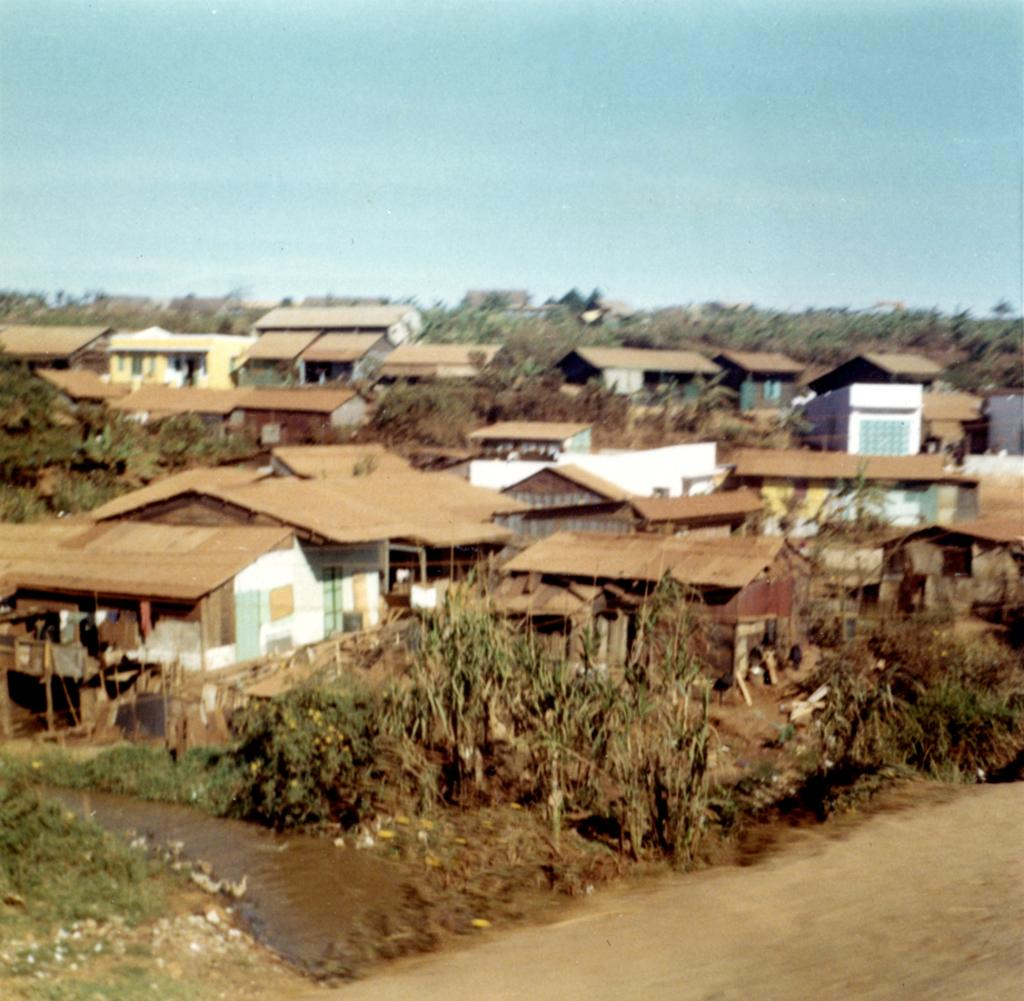What type of vegetation can be seen in the image? There are trees in the image. What type of structures are present in the image? There are houses in the image. What is the primary mode of transportation visible in the image? There is a road in the image. What is visible in the background of the image? The sky is visible in the background of the image. Where is the square located in the image? There is no square present in the image. What type of adjustment is being made to the trees in the image? There is no adjustment being made to the trees in the image; they are stationary. What type of mine is visible in the image? There is no mine present in the image. 